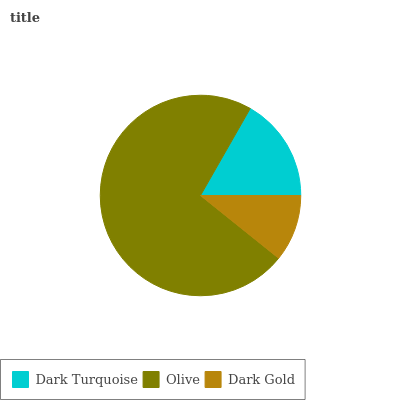Is Dark Gold the minimum?
Answer yes or no. Yes. Is Olive the maximum?
Answer yes or no. Yes. Is Olive the minimum?
Answer yes or no. No. Is Dark Gold the maximum?
Answer yes or no. No. Is Olive greater than Dark Gold?
Answer yes or no. Yes. Is Dark Gold less than Olive?
Answer yes or no. Yes. Is Dark Gold greater than Olive?
Answer yes or no. No. Is Olive less than Dark Gold?
Answer yes or no. No. Is Dark Turquoise the high median?
Answer yes or no. Yes. Is Dark Turquoise the low median?
Answer yes or no. Yes. Is Olive the high median?
Answer yes or no. No. Is Olive the low median?
Answer yes or no. No. 